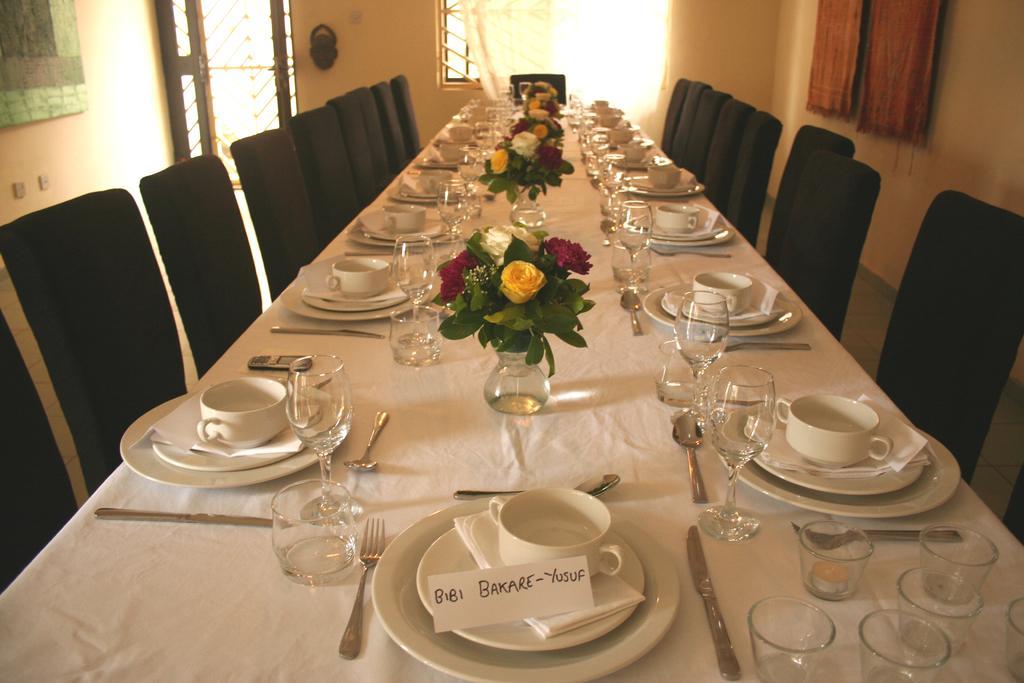Can you describe this image briefly? there is a dining table near to it there are many chairs on the table there are many things 